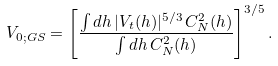<formula> <loc_0><loc_0><loc_500><loc_500>V _ { 0 ; G S } = \left [ \frac { \int d h \, | V _ { t } ( h ) | ^ { 5 / 3 } \, C _ { N } ^ { 2 } ( h ) } { \int d h \, C _ { N } ^ { 2 } ( h ) } \right ] ^ { 3 / 5 } .</formula> 